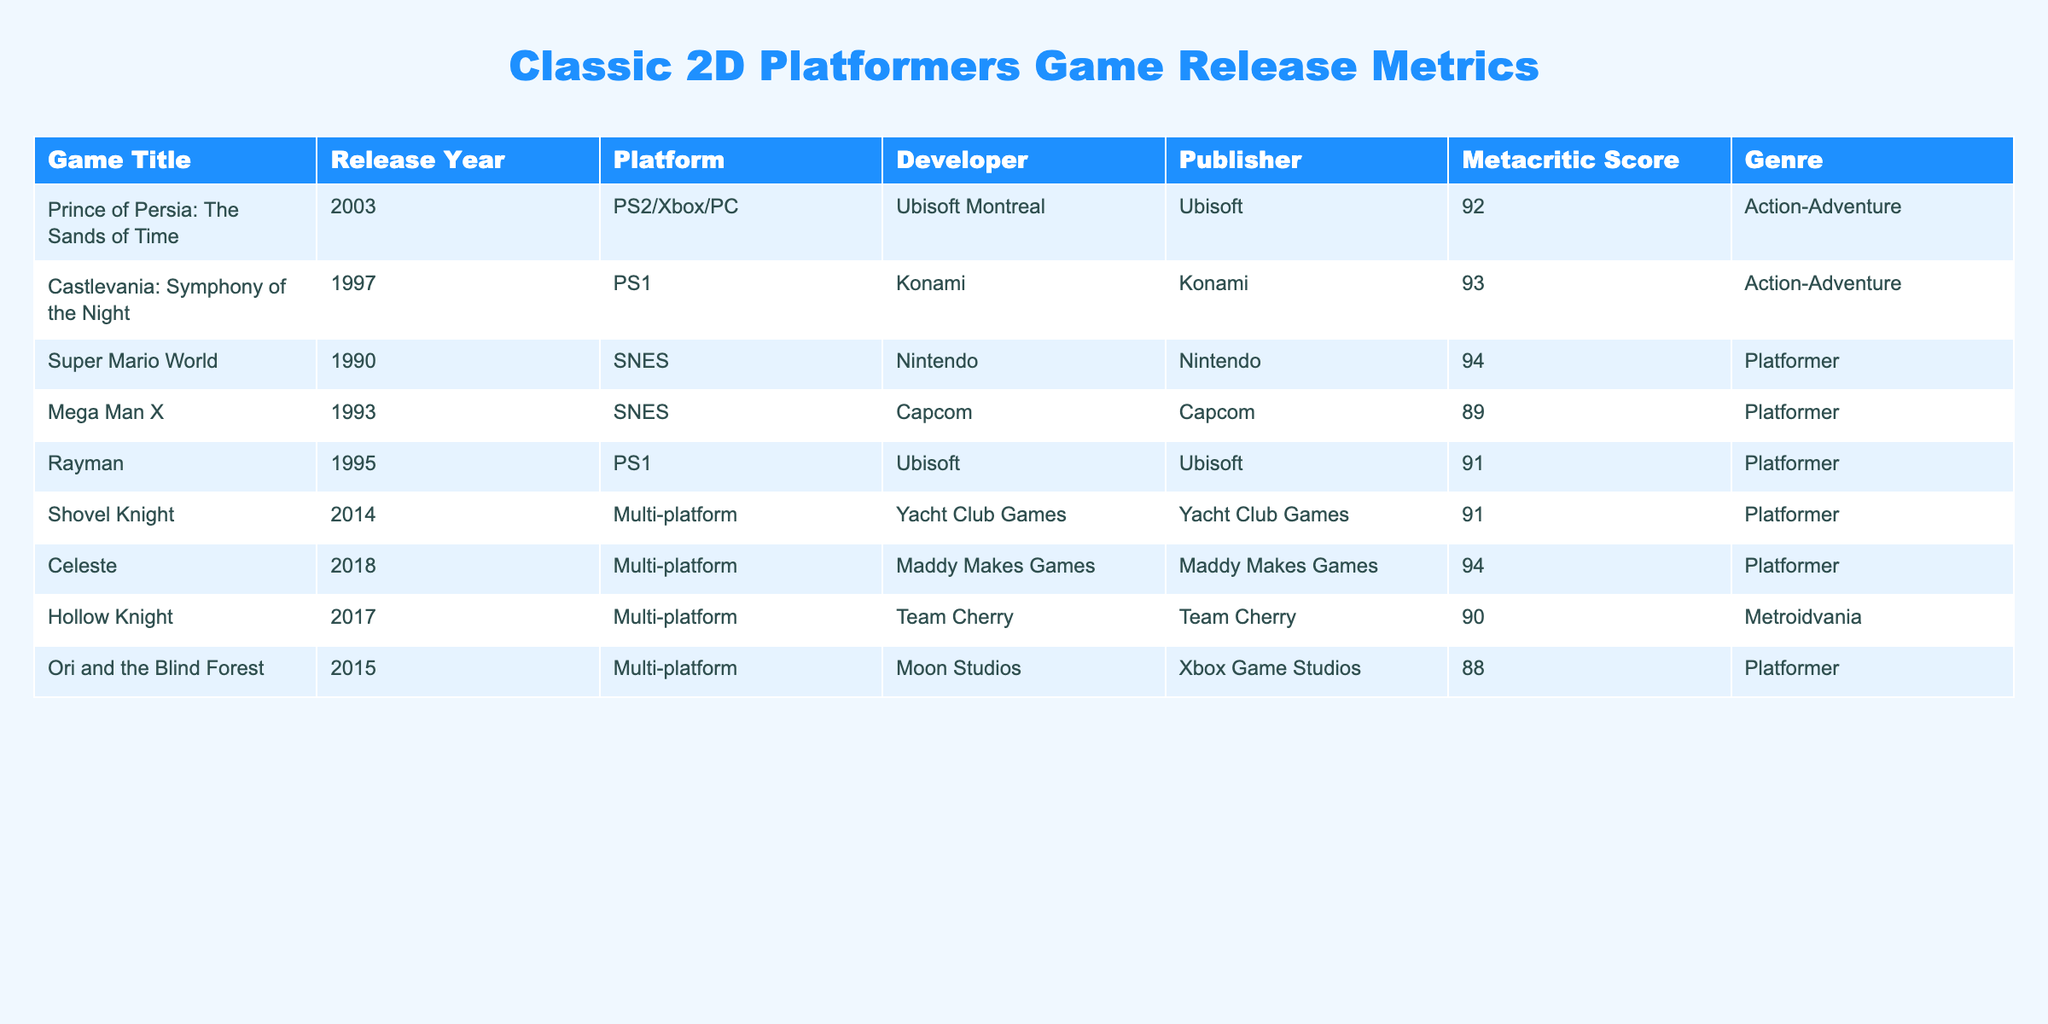What is the highest Metacritic score in the table? The highest Metacritic score listed is 94, which corresponds to "Super Mario World" and "Celeste".
Answer: 94 How many games were released before the year 2000? The games released before the year 2000 are "Super Mario World" (1990), "Mega Man X" (1993), "Castlevania: Symphony of the Night" (1997), and "Rayman" (1995). There are a total of 4 games released before 2000.
Answer: 4 Which developer published "Prince of Persia: The Sands of Time"? The developer and publisher for "Prince of Persia: The Sands of Time" is Ubisoft Montreal and Ubisoft, respectively. Both roles are filled by the same company, Ubisoft.
Answer: Ubisoft What is the average Metacritic score of all games listed? To find the average, sum all Metacritic scores: 92 + 93 + 94 + 89 + 91 + 91 + 94 + 90 + 88 = 820. There are 9 games. Divide the total by the number of games: 820 / 9 = 91.11. The average Metacritic score of all games is approximately 91.11.
Answer: 91.11 Is "Ori and the Blind Forest" rated higher than "Hollow Knight"? "Ori and the Blind Forest" has a Metacritic score of 88, while "Hollow Knight" has a score of 90. Thus, "Ori and the Blind Forest" is not rated higher than "Hollow Knight", making the statement false.
Answer: No How many of the games in the table were developed by Ubisoft? The games developed by Ubisoft are "Prince of Persia: The Sands of Time" and "Rayman", making a total of 2 games developed by Ubisoft.
Answer: 2 Which game has the lowest Metacritic score and what is that score? The game with the lowest Metacritic score is "Ori and the Blind Forest", which has a score of 88.
Answer: 88 Are there more games on the table developed for PS1 than those for SNES? There are 2 games listed for PS1 ("Castlevania: Symphony of the Night" and "Rayman") and 2 games for SNES ("Super Mario World" and "Mega Man X"). Therefore, there is an equal number, so the statement is false.
Answer: No Which platform has the highest number of titles listed? The Multi-platform category has 4 titles: "Shovel Knight," "Celeste," "Hollow Knight," and "Ori and the Blind Forest." Other platforms like PS2/Xbox/PC, PS1, and SNES have fewer titles, making Multi-platform the highest.
Answer: Multi-platform 